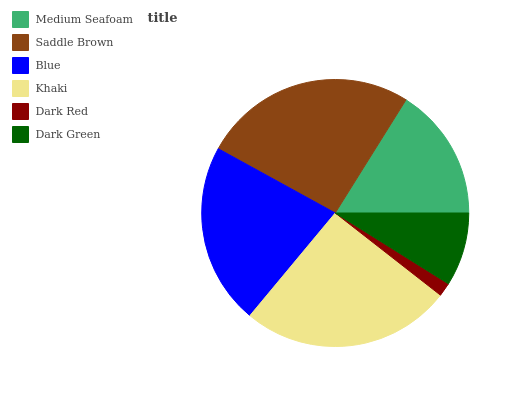Is Dark Red the minimum?
Answer yes or no. Yes. Is Saddle Brown the maximum?
Answer yes or no. Yes. Is Blue the minimum?
Answer yes or no. No. Is Blue the maximum?
Answer yes or no. No. Is Saddle Brown greater than Blue?
Answer yes or no. Yes. Is Blue less than Saddle Brown?
Answer yes or no. Yes. Is Blue greater than Saddle Brown?
Answer yes or no. No. Is Saddle Brown less than Blue?
Answer yes or no. No. Is Blue the high median?
Answer yes or no. Yes. Is Medium Seafoam the low median?
Answer yes or no. Yes. Is Dark Green the high median?
Answer yes or no. No. Is Dark Green the low median?
Answer yes or no. No. 